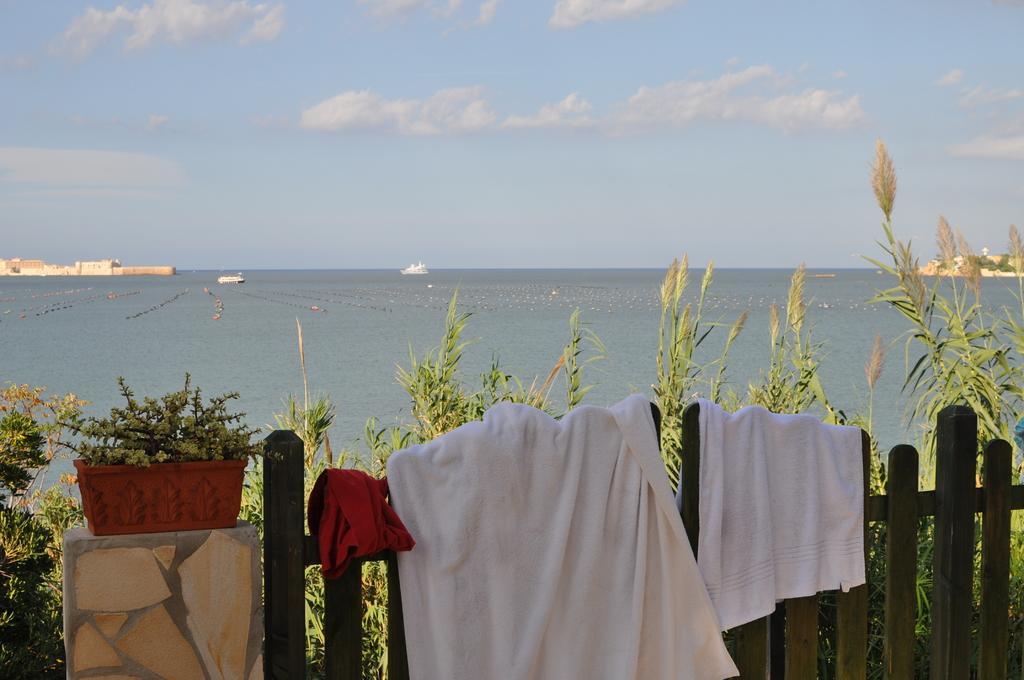Could you give a brief overview of what you see in this image? At the bottom we can see the towels on the wooden fencing. Beside that we can see the plant on the pot which is kept on the pillar. In the background we can see some boats on the water. On the left we can see the building. On the right we can see the trees on the mountain. At the top we can see the sky and clouds. 